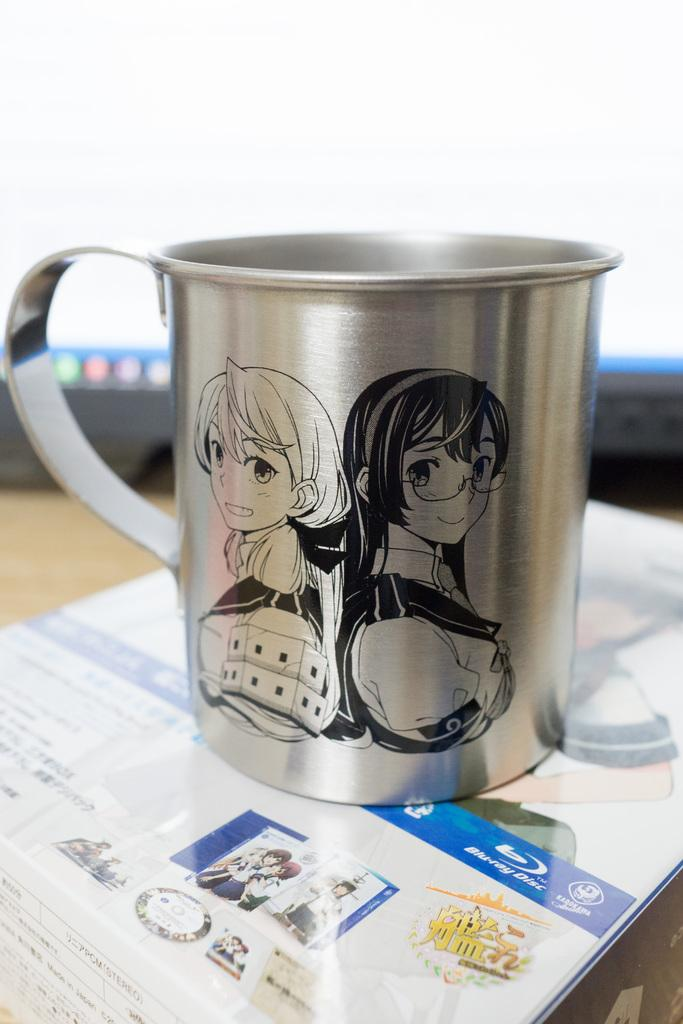What object is visible in the image? There is a cup in the image. Where is the cup located? The cup is on a table. Can you describe the setting in which the cup is located? The image may have been taken in a room. Can you tell me how many horses are in the image? There are no horses present in the image; it features a cup on a table. What time of day is it in the image, given the presence of the sun? There is no sun visible in the image, so it cannot be determined from the image alone. 